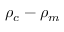Convert formula to latex. <formula><loc_0><loc_0><loc_500><loc_500>\rho _ { c } - \rho _ { m }</formula> 